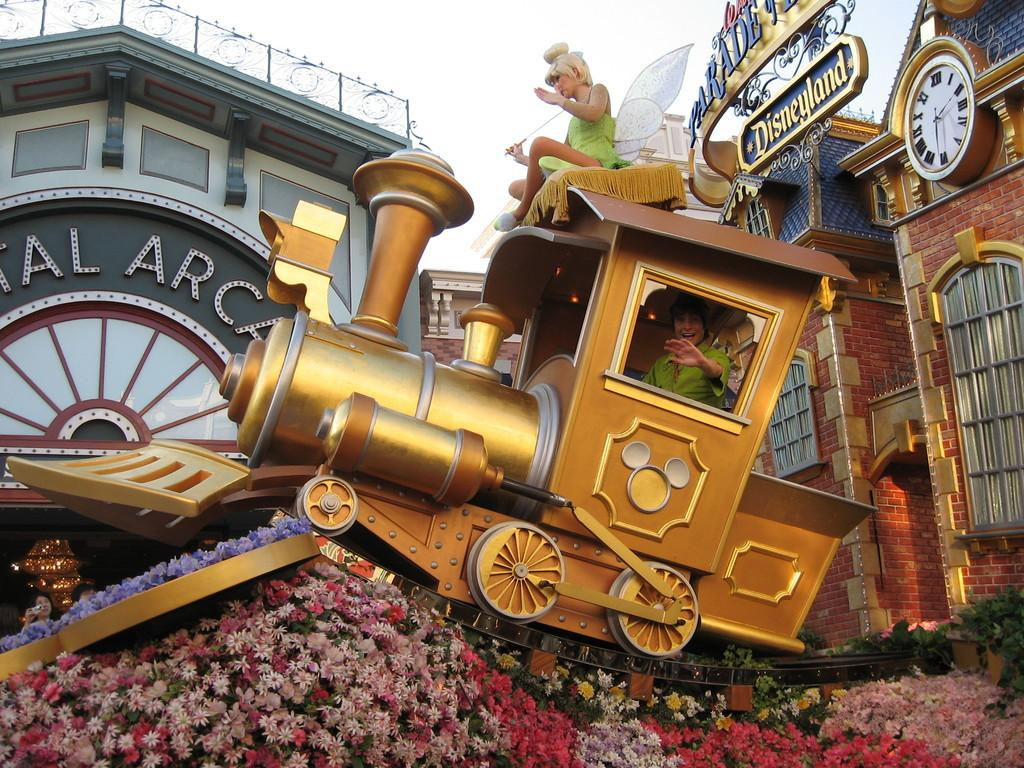<image>
Provide a brief description of the given image. A person waves from inside a fake train engine at Disneyland. 